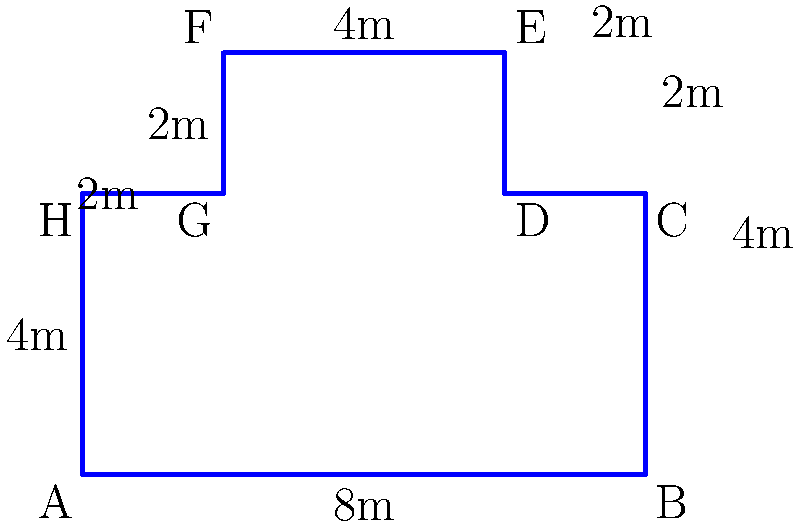As part of planning a new data center for your cloud computing PaaS solution, you need to calculate the perimeter of an irregularly shaped floor plan. The floor plan is represented by the diagram above, where each small square represents 1 square meter. What is the perimeter of this data center floor plan in meters? To calculate the perimeter, we need to sum up the lengths of all sides of the irregular shape. Let's break it down step by step:

1. Bottom side (A to B): 8m
2. Right side (B to C): 4m
3. Right side (C to D): 2m
4. Right side (D to E): 2m
5. Top side (E to F): 4m
6. Left side (F to G): 2m
7. Left side (G to H): 2m
8. Left side (H to A): 4m

Now, let's sum up all these lengths:

$$8 + 4 + 2 + 2 + 4 + 2 + 2 + 4 = 28$$

Therefore, the total perimeter of the data center floor plan is 28 meters.

This calculation is crucial for planning purposes, such as determining the length of network cables needed for the perimeter, planning cooling systems, or estimating the cost of materials for constructing the outer walls of the data center.
Answer: 28 meters 